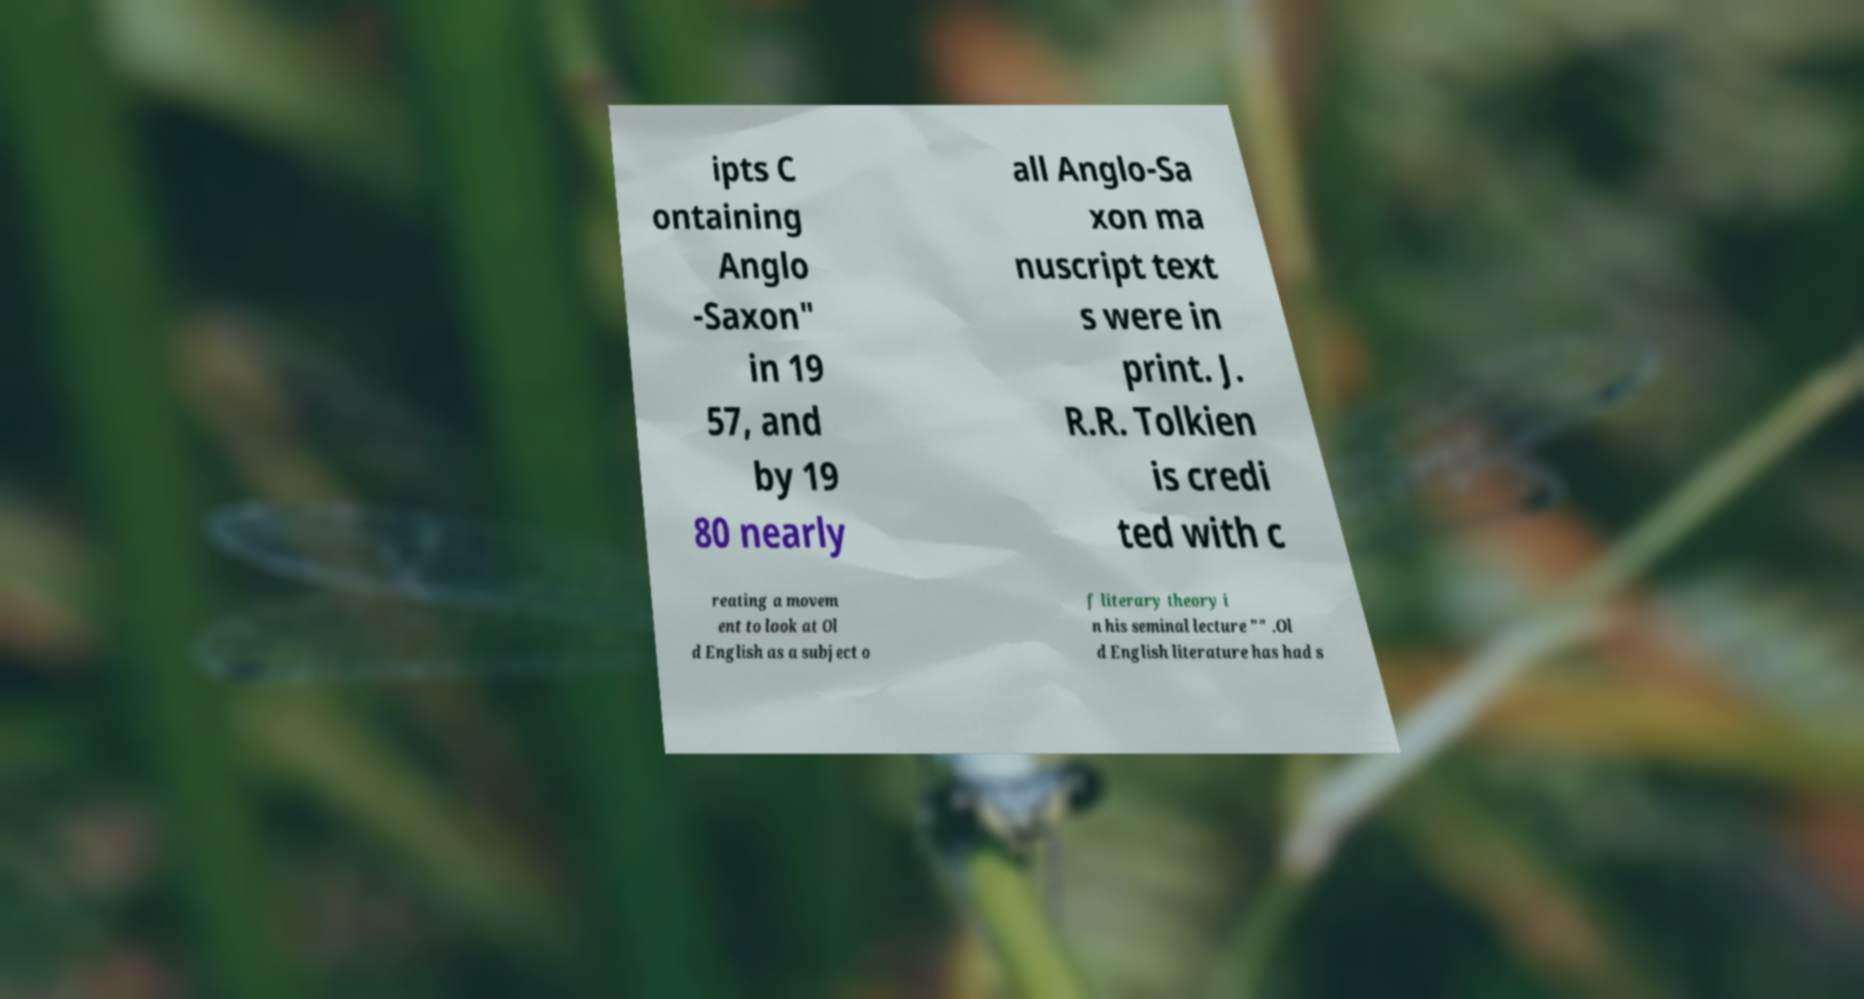Can you read and provide the text displayed in the image?This photo seems to have some interesting text. Can you extract and type it out for me? ipts C ontaining Anglo -Saxon" in 19 57, and by 19 80 nearly all Anglo-Sa xon ma nuscript text s were in print. J. R.R. Tolkien is credi ted with c reating a movem ent to look at Ol d English as a subject o f literary theory i n his seminal lecture "" .Ol d English literature has had s 